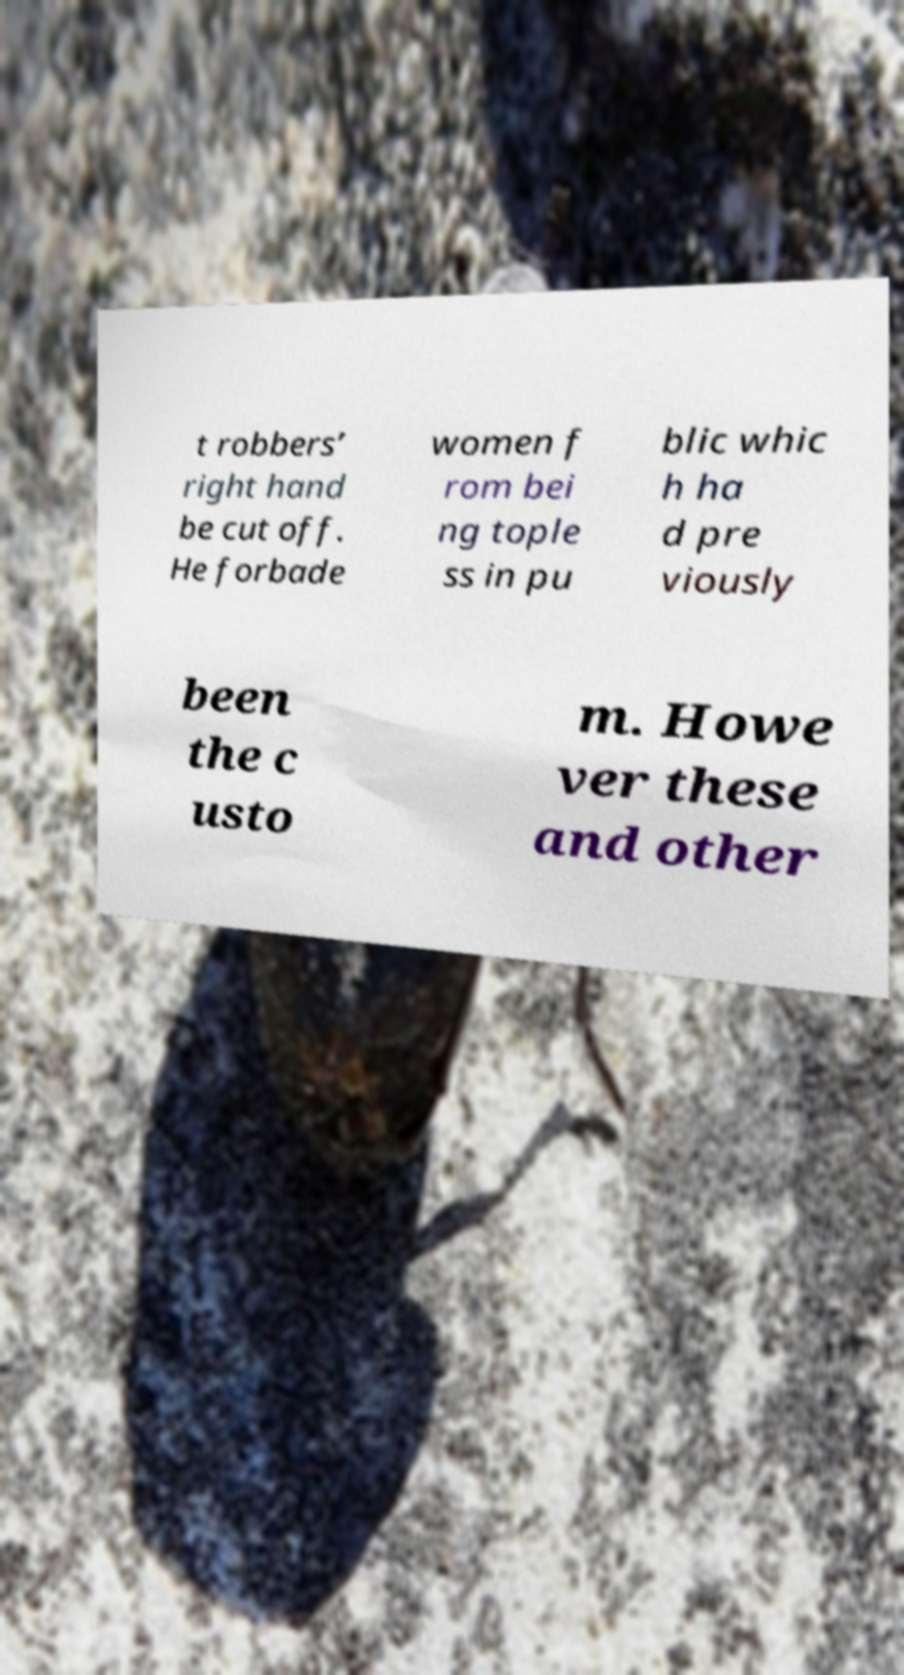I need the written content from this picture converted into text. Can you do that? t robbers’ right hand be cut off. He forbade women f rom bei ng tople ss in pu blic whic h ha d pre viously been the c usto m. Howe ver these and other 